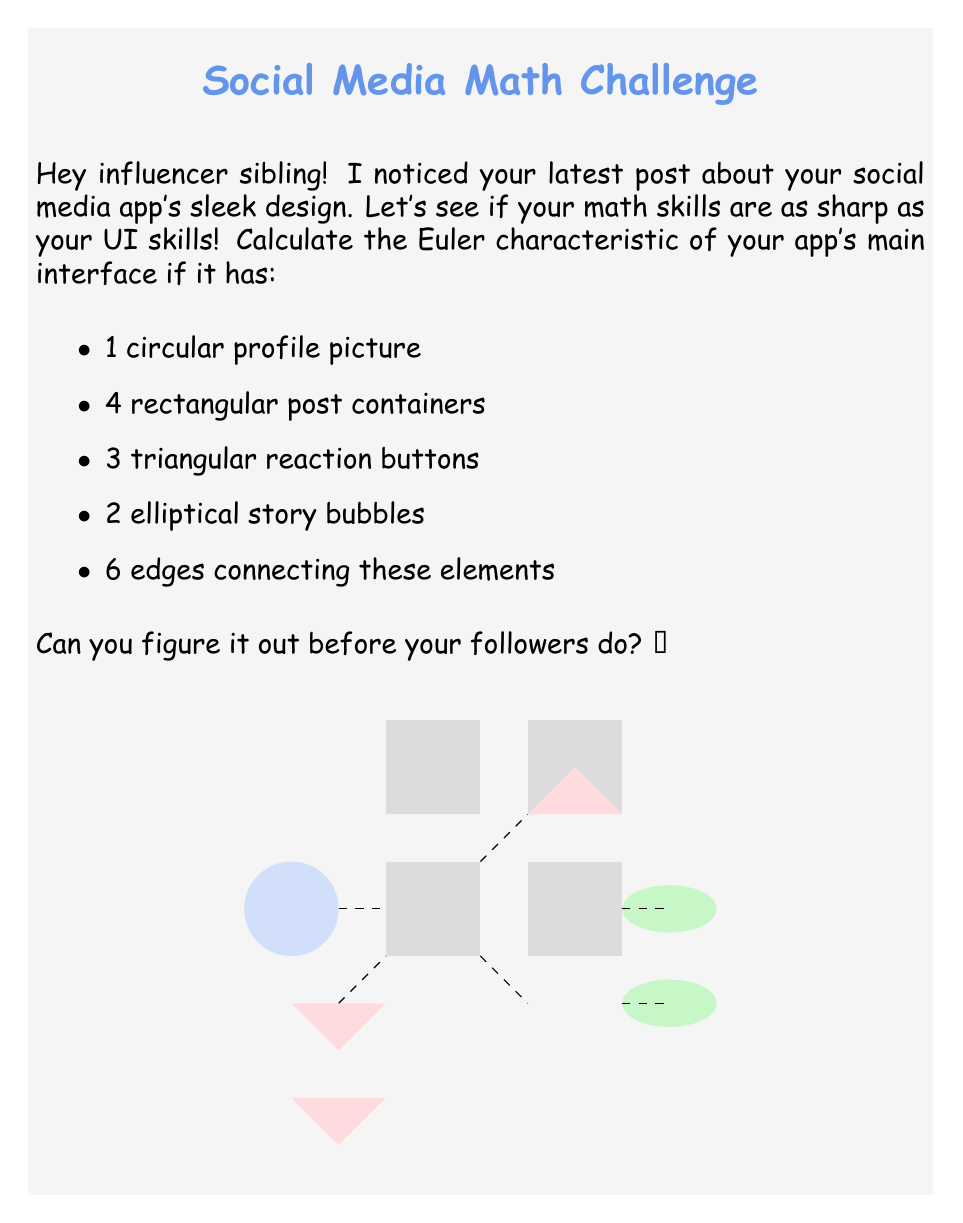Show me your answer to this math problem. To calculate the Euler characteristic, we'll use the formula:

$$\chi = V - E + F$$

Where:
$\chi$ is the Euler characteristic
$V$ is the number of vertices
$E$ is the number of edges
$F$ is the number of faces

Let's count each component:

1. Vertices (V):
   - 1 circular profile picture: 1 vertex
   - 4 rectangular post containers: 4 * 4 = 16 vertices
   - 3 triangular reaction buttons: 3 * 3 = 9 vertices
   - 2 elliptical story bubbles: 2 * 2 = 4 vertices
   Total vertices: $V = 1 + 16 + 9 + 4 = 30$

2. Edges (E):
   - 1 circular profile picture: 1 edge
   - 4 rectangular post containers: 4 * 4 = 16 edges
   - 3 triangular reaction buttons: 3 * 3 = 9 edges
   - 2 elliptical story bubbles: 2 * 2 = 4 edges
   - 6 connecting edges
   Total edges: $E = 1 + 16 + 9 + 4 + 6 = 36$

3. Faces (F):
   - 1 circular profile picture: 1 face
   - 4 rectangular post containers: 4 faces
   - 3 triangular reaction buttons: 3 faces
   - 2 elliptical story bubbles: 2 faces
   - 1 external face
   Total faces: $F = 1 + 4 + 3 + 2 + 1 = 11$

Now, we can plug these values into the Euler characteristic formula:

$$\chi = V - E + F = 30 - 36 + 11 = 5$$

Therefore, the Euler characteristic of the social media platform's user interface is 5.
Answer: $\chi = 5$ 